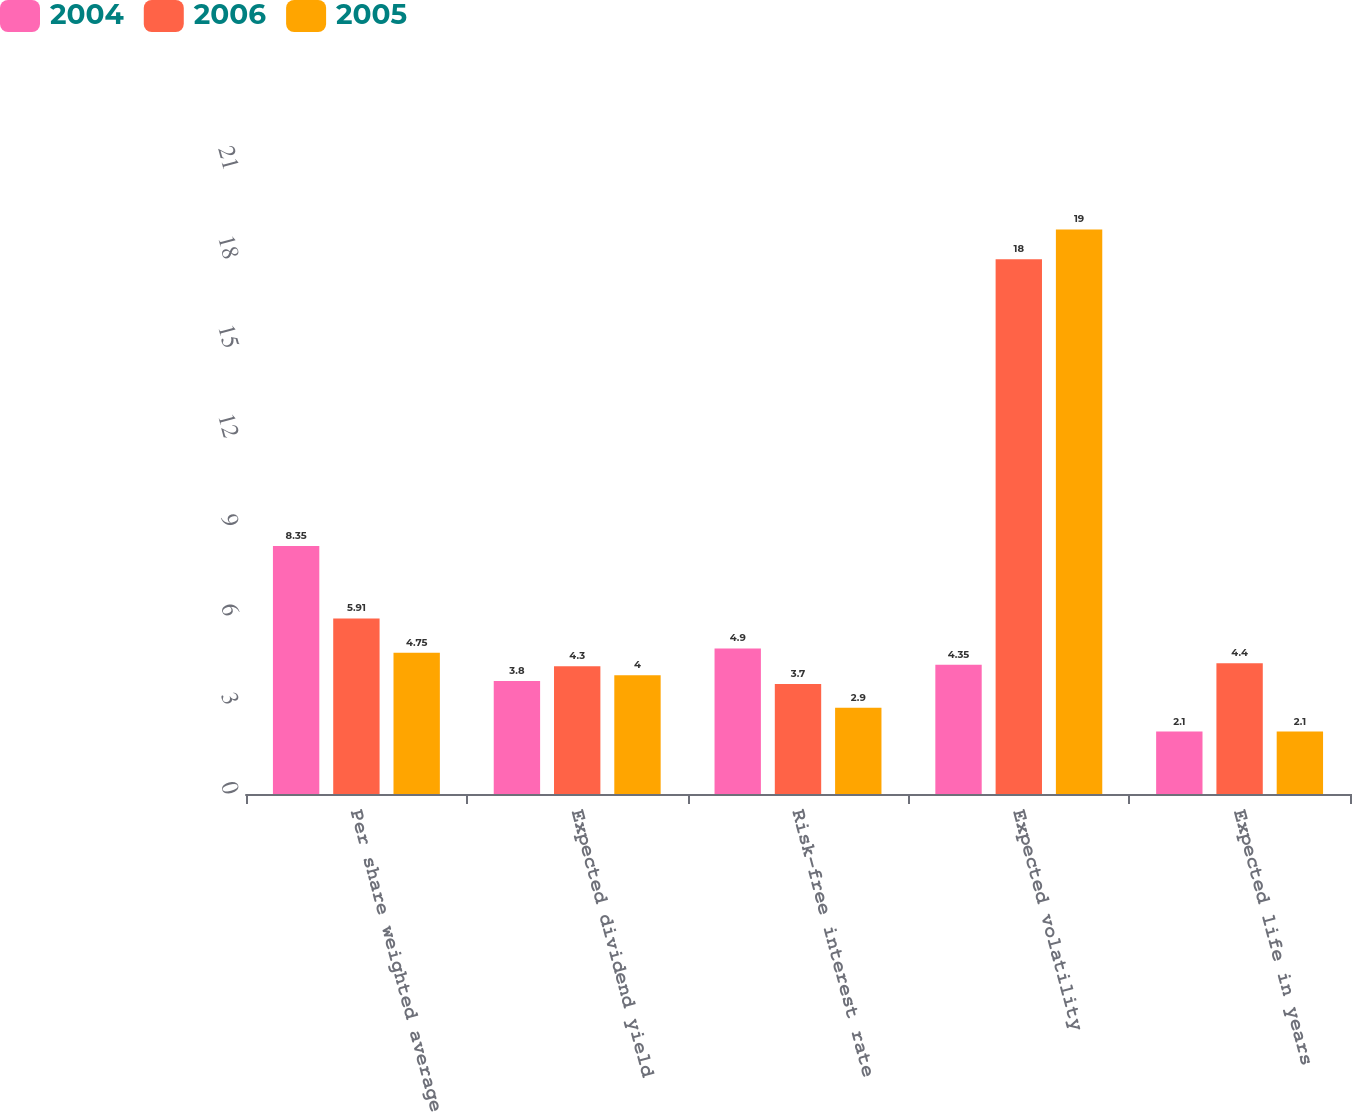<chart> <loc_0><loc_0><loc_500><loc_500><stacked_bar_chart><ecel><fcel>Per share weighted average<fcel>Expected dividend yield<fcel>Risk-free interest rate<fcel>Expected volatility<fcel>Expected life in years<nl><fcel>2004<fcel>8.35<fcel>3.8<fcel>4.9<fcel>4.35<fcel>2.1<nl><fcel>2006<fcel>5.91<fcel>4.3<fcel>3.7<fcel>18<fcel>4.4<nl><fcel>2005<fcel>4.75<fcel>4<fcel>2.9<fcel>19<fcel>2.1<nl></chart> 